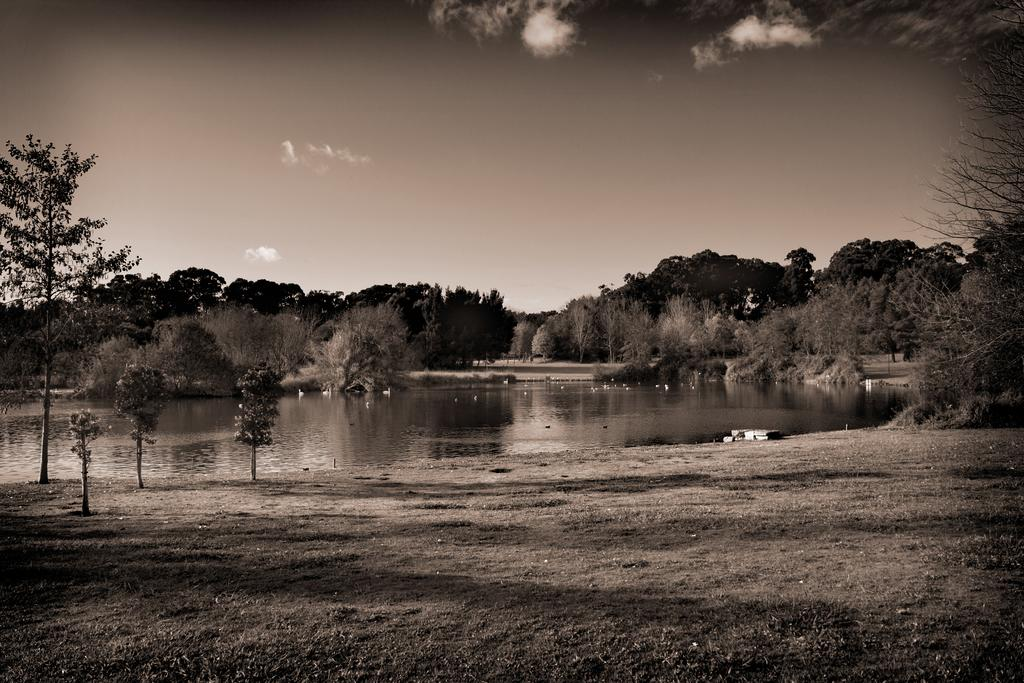What is the color scheme of the image? The image is black and white. What type of natural environment is depicted in the image? There are trees and a lake in the image, which suggests a natural setting. What can be seen on the ground in the image? The ground is visible in the image. What part of the sky is visible in the image? The sky is visible in the image, and there is a cloud present. Where is the swing located in the image? There is no swing present in the image. What type of cord is used to hang the need in the image? There is no cord or need present in the image. 